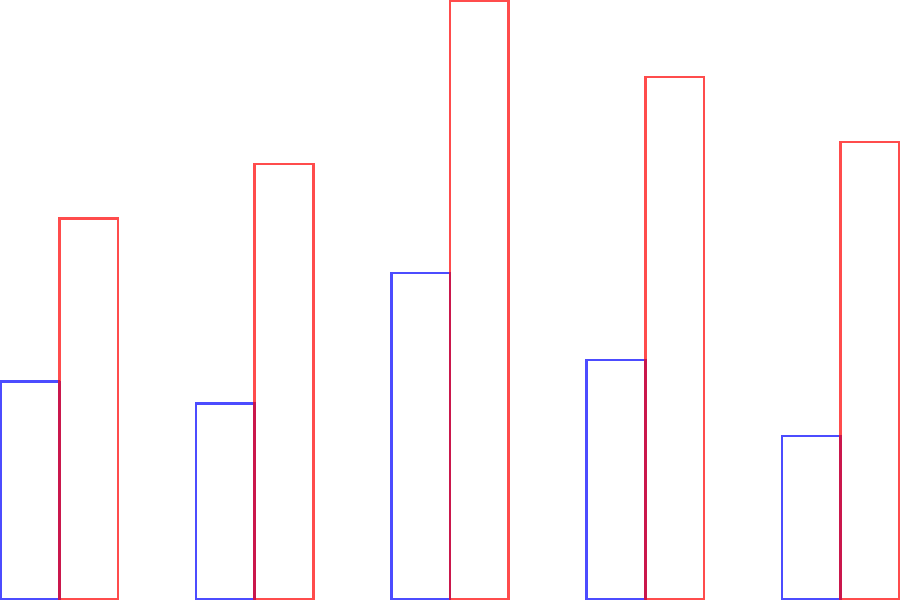The bar chart shows the average home prices in five Denver neighborhoods in 2010 and 2020. Which neighborhood experienced the highest percentage increase in average home price during this period? To find the neighborhood with the highest percentage increase, we need to calculate the percentage change for each neighborhood and compare:

1. Capitol Hill:
   2010: $200,000, 2020: $350,000
   Percentage increase = $(350000 - 200000) / 200000 \times 100\% = 75\%$

2. Five Points:
   2010: $180,000, 2020: $400,000
   Percentage increase = $(400000 - 180000) / 180000 \times 100\% = 122.22\%$

3. LoDo:
   2010: $300,000, 2020: $550,000
   Percentage increase = $(550000 - 300000) / 300000 \times 100\% = 83.33\%$

4. Highlands:
   2010: $220,000, 2020: $480,000
   Percentage increase = $(480000 - 220000) / 220000 \times 100\% = 118.18\%$

5. RiNo:
   2010: $150,000, 2020: $420,000
   Percentage increase = $(420000 - 150000) / 150000 \times 100\% = 180\%$

Comparing these percentages, we can see that RiNo had the highest percentage increase at 180%.
Answer: RiNo 